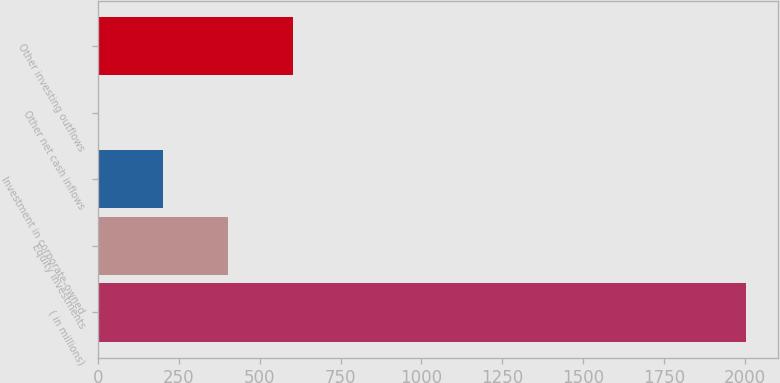Convert chart to OTSL. <chart><loc_0><loc_0><loc_500><loc_500><bar_chart><fcel>( in millions)<fcel>Equity investments<fcel>Investment in corporate-owned<fcel>Other net cash inflows<fcel>Other investing outflows<nl><fcel>2004<fcel>402.4<fcel>202.2<fcel>2<fcel>602.6<nl></chart> 